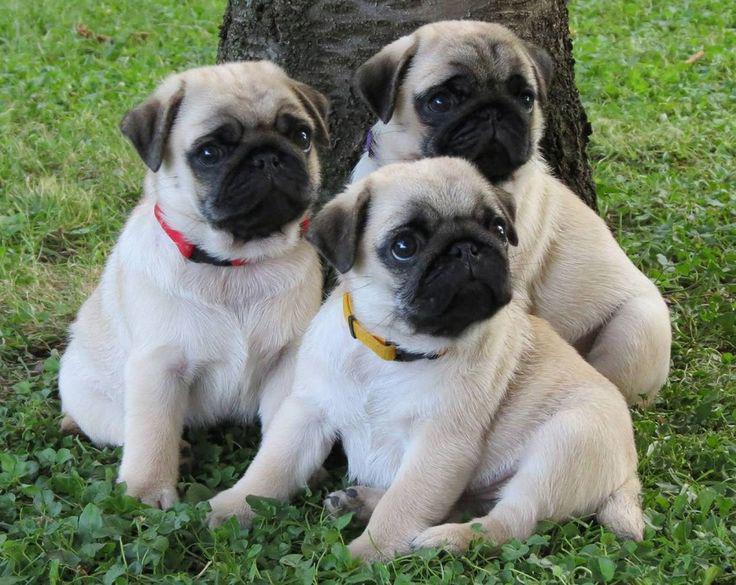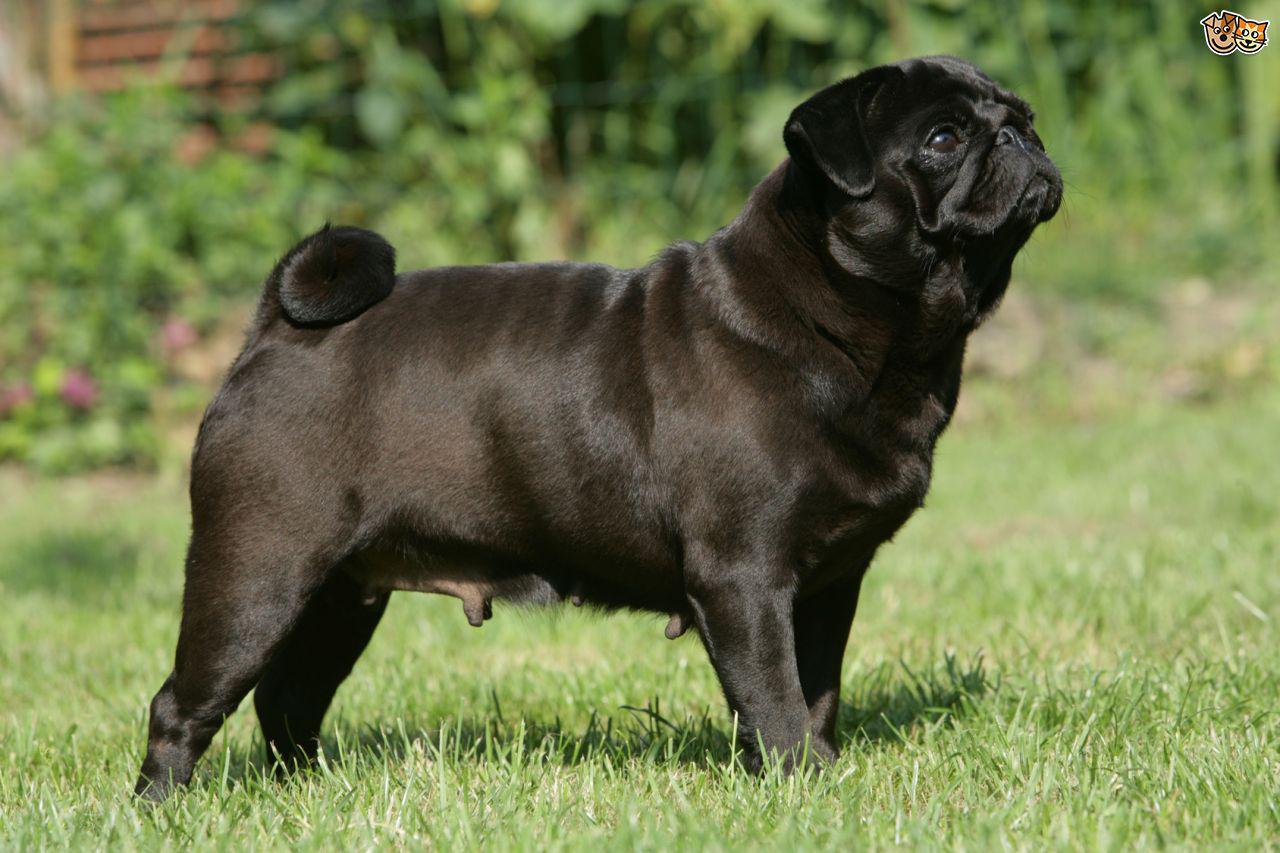The first image is the image on the left, the second image is the image on the right. Examine the images to the left and right. Is the description "The right image contains at least three dogs." accurate? Answer yes or no. No. The first image is the image on the left, the second image is the image on the right. Evaluate the accuracy of this statement regarding the images: "A dog is running.". Is it true? Answer yes or no. No. 